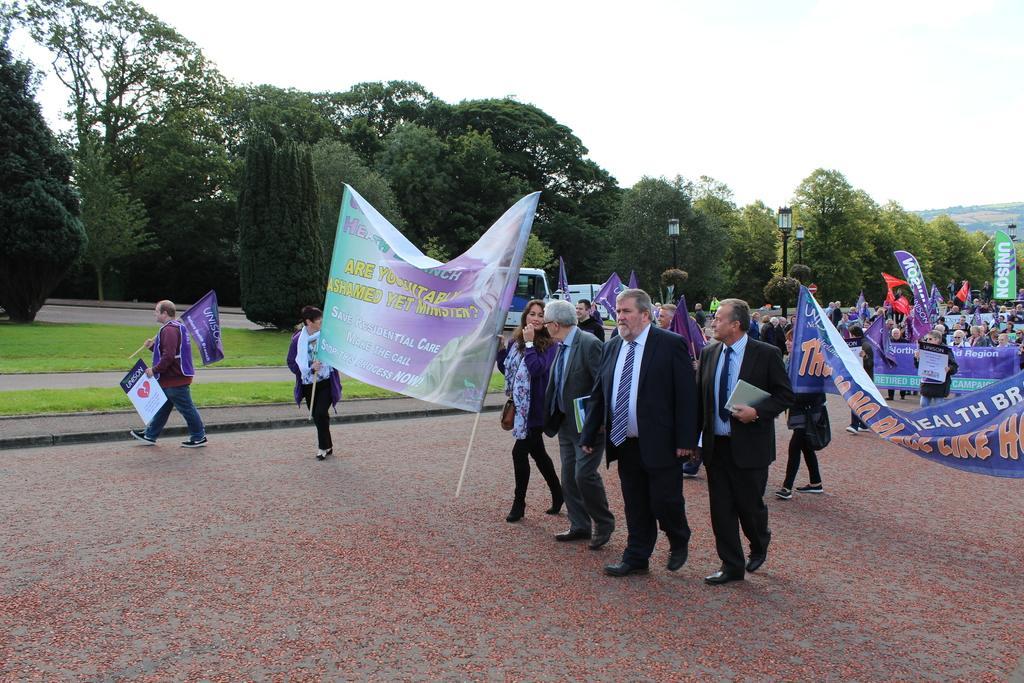Describe this image in one or two sentences. As we can see in the image there are few people here and there, flags, banners, trees, street lamps and sky. 